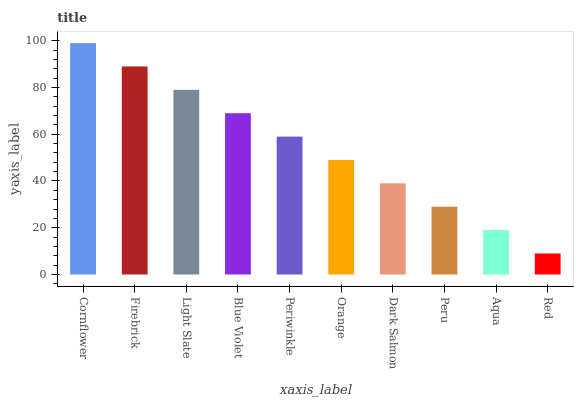Is Red the minimum?
Answer yes or no. Yes. Is Cornflower the maximum?
Answer yes or no. Yes. Is Firebrick the minimum?
Answer yes or no. No. Is Firebrick the maximum?
Answer yes or no. No. Is Cornflower greater than Firebrick?
Answer yes or no. Yes. Is Firebrick less than Cornflower?
Answer yes or no. Yes. Is Firebrick greater than Cornflower?
Answer yes or no. No. Is Cornflower less than Firebrick?
Answer yes or no. No. Is Periwinkle the high median?
Answer yes or no. Yes. Is Orange the low median?
Answer yes or no. Yes. Is Cornflower the high median?
Answer yes or no. No. Is Firebrick the low median?
Answer yes or no. No. 